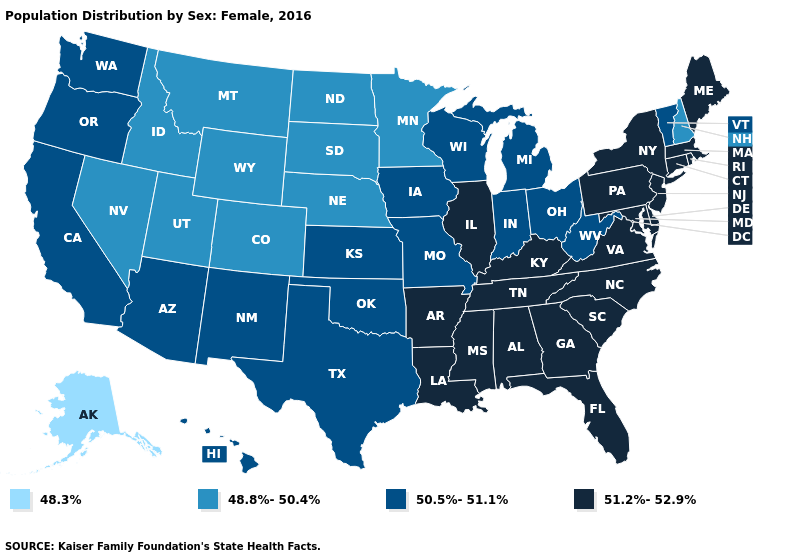Among the states that border Illinois , does Kentucky have the lowest value?
Give a very brief answer. No. Name the states that have a value in the range 48.3%?
Write a very short answer. Alaska. Name the states that have a value in the range 51.2%-52.9%?
Concise answer only. Alabama, Arkansas, Connecticut, Delaware, Florida, Georgia, Illinois, Kentucky, Louisiana, Maine, Maryland, Massachusetts, Mississippi, New Jersey, New York, North Carolina, Pennsylvania, Rhode Island, South Carolina, Tennessee, Virginia. Does Vermont have the same value as Oregon?
Write a very short answer. Yes. Name the states that have a value in the range 51.2%-52.9%?
Keep it brief. Alabama, Arkansas, Connecticut, Delaware, Florida, Georgia, Illinois, Kentucky, Louisiana, Maine, Maryland, Massachusetts, Mississippi, New Jersey, New York, North Carolina, Pennsylvania, Rhode Island, South Carolina, Tennessee, Virginia. Does North Dakota have the highest value in the MidWest?
Keep it brief. No. Name the states that have a value in the range 51.2%-52.9%?
Short answer required. Alabama, Arkansas, Connecticut, Delaware, Florida, Georgia, Illinois, Kentucky, Louisiana, Maine, Maryland, Massachusetts, Mississippi, New Jersey, New York, North Carolina, Pennsylvania, Rhode Island, South Carolina, Tennessee, Virginia. What is the value of South Carolina?
Give a very brief answer. 51.2%-52.9%. Does Alaska have a higher value than New York?
Answer briefly. No. How many symbols are there in the legend?
Quick response, please. 4. What is the value of Arizona?
Write a very short answer. 50.5%-51.1%. What is the value of New Mexico?
Be succinct. 50.5%-51.1%. What is the lowest value in the USA?
Short answer required. 48.3%. 